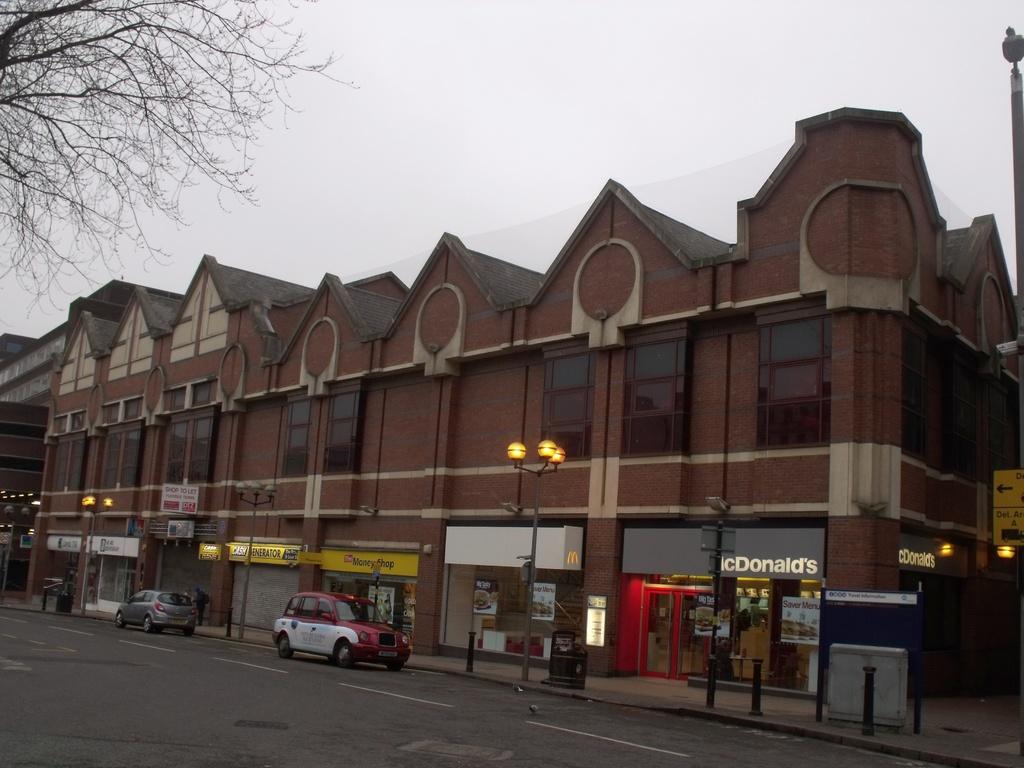What does the sign on the right say?
Your response must be concise. Mcdonalds. 